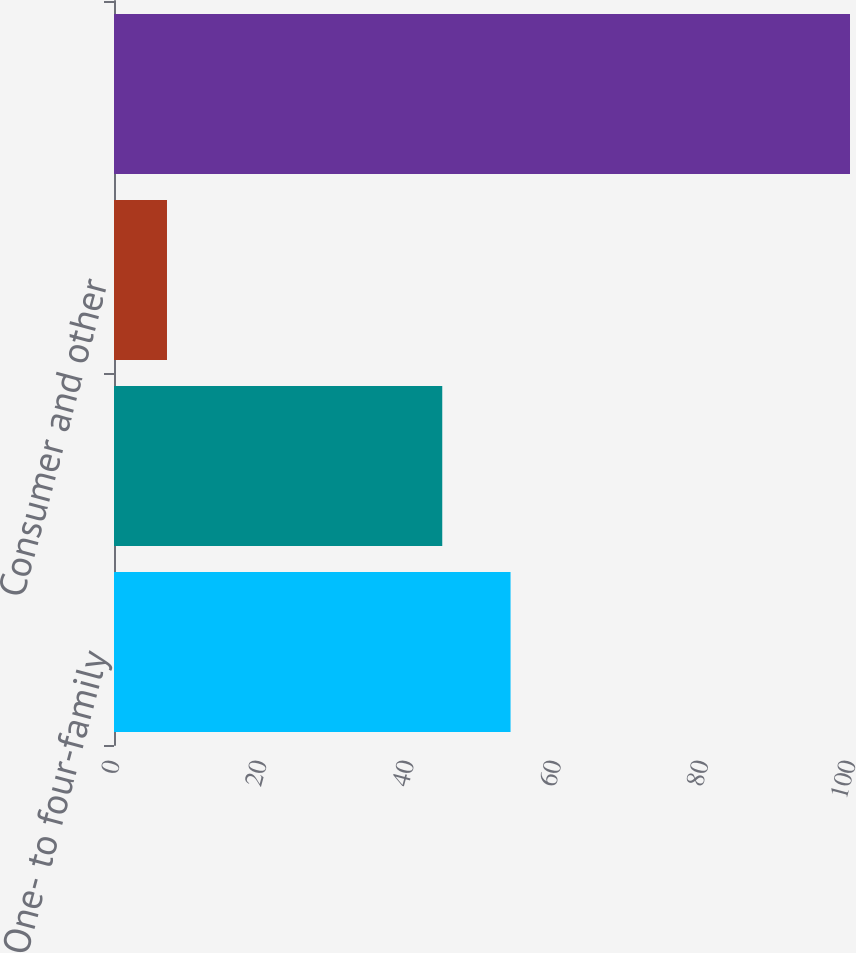Convert chart. <chart><loc_0><loc_0><loc_500><loc_500><bar_chart><fcel>One- to four-family<fcel>Home equity<fcel>Consumer and other<fcel>Total loans receivable<nl><fcel>53.88<fcel>44.6<fcel>7.2<fcel>100<nl></chart> 